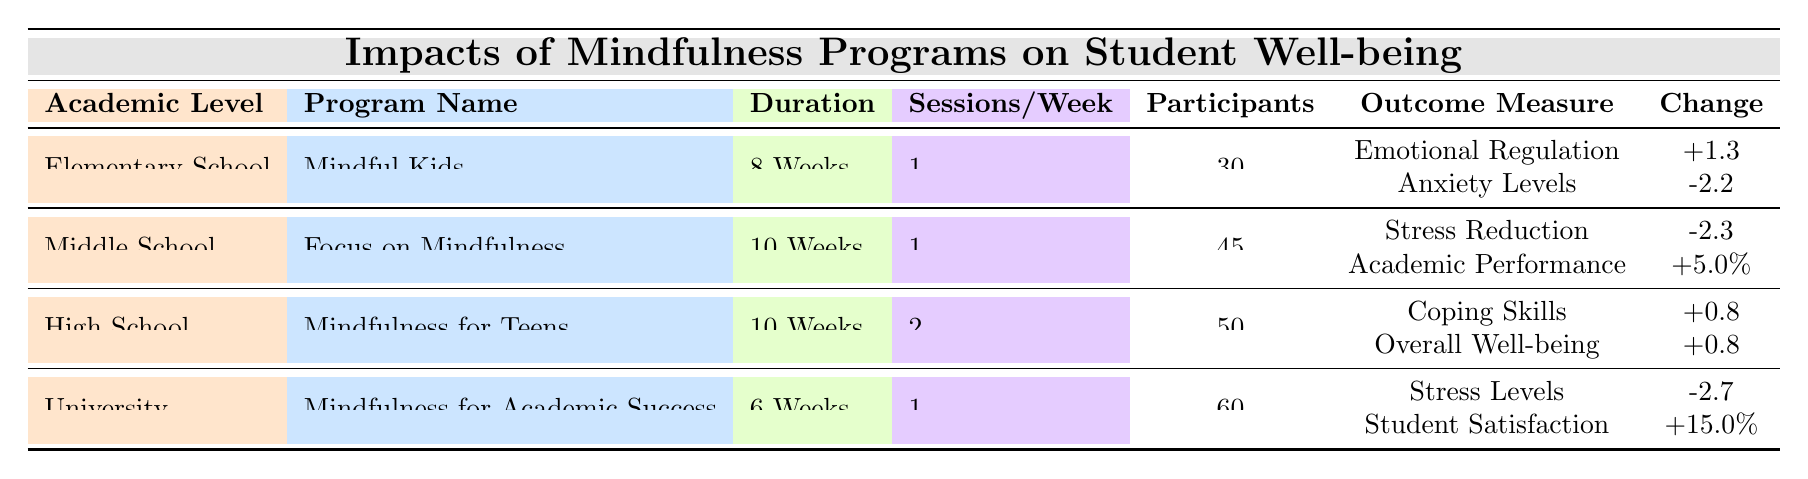What is the program name for students in Middle School? The table shows the program name under the "Middle School" category, which is "Focus on Mindfulness."
Answer: Focus on Mindfulness How many participants were involved in the University mindfulness program? According to the table, the University mindfulness program had 60 participants listed in the corresponding column.
Answer: 60 What was the change in Emotional Regulation for Elementary School students? The table indicates that the change in Emotional Regulation for the "Mindful Kids" program in Elementary School was +1.3, based on the Outcome Measures section.
Answer: +1.3 Is the change in Anxiety Levels for Elementary School students positive or negative? The value recorded in the table for the change in Anxiety Levels is -2.2, which is negative, indicating that anxiety levels decreased after the program.
Answer: Negative What is the average change in coping skills and overall well-being for High School students? The average change is calculated by adding the changes (+0.8 for coping skills and +0.8 for overall well-being) and then dividing by 2. This gives (0.8 + 0.8) / 2 = 0.8.
Answer: 0.8 Did the mindfulness program at the University lead to an increase in student satisfaction? The change in student satisfaction for the University program is +15.0%, indicating a positive outcome. Thus, the answer is yes.
Answer: Yes Which academic level showed the greatest reduction in stress levels? The table shows the change in stress levels for the University program as -2.7. For Middle School, it is -2.3. Since -2.7 is less than -2.3, the University showed the greatest reduction in stress levels.
Answer: University What was the difference in change for Academic Performance compared to Stress Reduction in Middle School? The change in Academic Performance is +5.0%, while the change in Stress Reduction is -2.3. The difference is 5.0 - (-2.3) = 7.3.
Answer: 7.3 What was the duration of the "Mindfulness for Teens" program in High School? The duration of the "Mindfulness for Teens" program is listed in the table as 10 Weeks.
Answer: 10 Weeks 